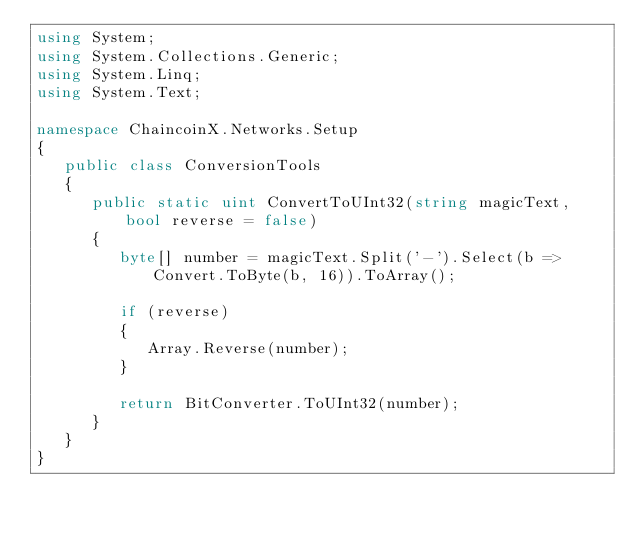Convert code to text. <code><loc_0><loc_0><loc_500><loc_500><_C#_>using System;
using System.Collections.Generic;
using System.Linq;
using System.Text;

namespace ChaincoinX.Networks.Setup
{
   public class ConversionTools
   {
      public static uint ConvertToUInt32(string magicText, bool reverse = false)
      {
         byte[] number = magicText.Split('-').Select(b => Convert.ToByte(b, 16)).ToArray();

         if (reverse)
         {
            Array.Reverse(number);
         }

         return BitConverter.ToUInt32(number);
      }
   }
}
</code> 